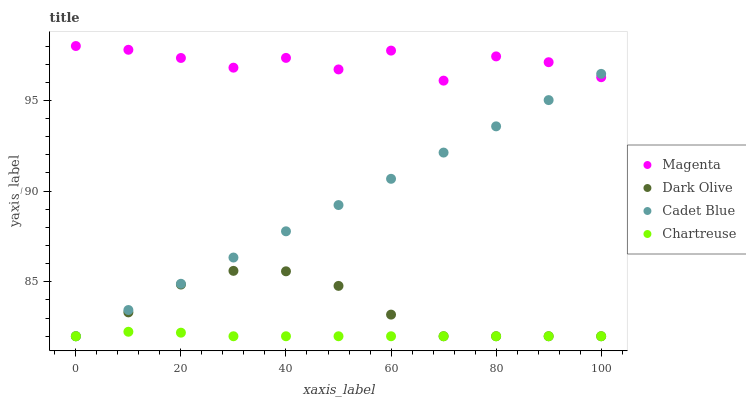Does Chartreuse have the minimum area under the curve?
Answer yes or no. Yes. Does Magenta have the maximum area under the curve?
Answer yes or no. Yes. Does Dark Olive have the minimum area under the curve?
Answer yes or no. No. Does Dark Olive have the maximum area under the curve?
Answer yes or no. No. Is Cadet Blue the smoothest?
Answer yes or no. Yes. Is Magenta the roughest?
Answer yes or no. Yes. Is Dark Olive the smoothest?
Answer yes or no. No. Is Dark Olive the roughest?
Answer yes or no. No. Does Cadet Blue have the lowest value?
Answer yes or no. Yes. Does Magenta have the lowest value?
Answer yes or no. No. Does Magenta have the highest value?
Answer yes or no. Yes. Does Dark Olive have the highest value?
Answer yes or no. No. Is Dark Olive less than Magenta?
Answer yes or no. Yes. Is Magenta greater than Dark Olive?
Answer yes or no. Yes. Does Chartreuse intersect Dark Olive?
Answer yes or no. Yes. Is Chartreuse less than Dark Olive?
Answer yes or no. No. Is Chartreuse greater than Dark Olive?
Answer yes or no. No. Does Dark Olive intersect Magenta?
Answer yes or no. No. 